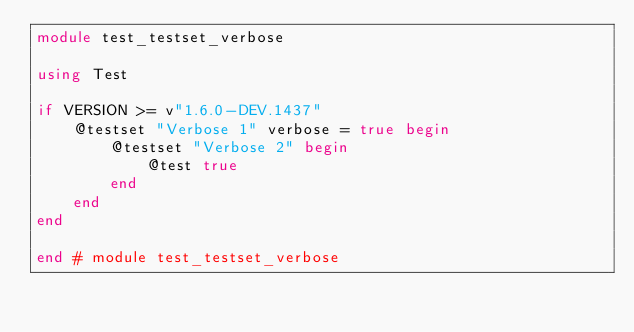Convert code to text. <code><loc_0><loc_0><loc_500><loc_500><_Julia_>module test_testset_verbose

using Test

if VERSION >= v"1.6.0-DEV.1437"
    @testset "Verbose 1" verbose = true begin
        @testset "Verbose 2" begin
            @test true
        end
    end
end

end # module test_testset_verbose
</code> 